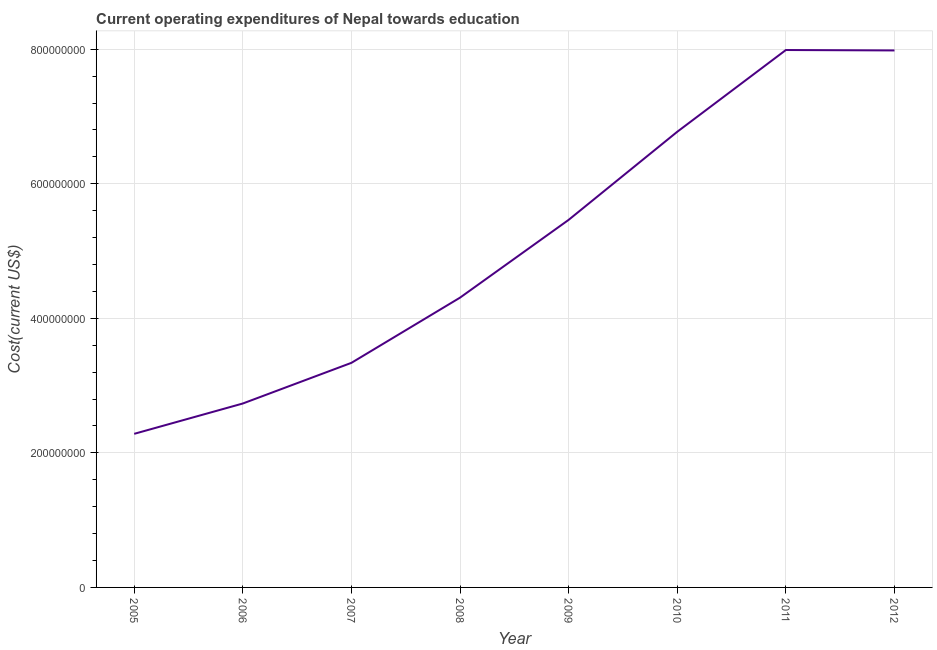What is the education expenditure in 2006?
Your answer should be very brief. 2.73e+08. Across all years, what is the maximum education expenditure?
Your answer should be compact. 7.99e+08. Across all years, what is the minimum education expenditure?
Provide a short and direct response. 2.28e+08. In which year was the education expenditure minimum?
Make the answer very short. 2005. What is the sum of the education expenditure?
Provide a succinct answer. 4.09e+09. What is the difference between the education expenditure in 2005 and 2009?
Ensure brevity in your answer.  -3.18e+08. What is the average education expenditure per year?
Keep it short and to the point. 5.11e+08. What is the median education expenditure?
Your response must be concise. 4.89e+08. In how many years, is the education expenditure greater than 720000000 US$?
Ensure brevity in your answer.  2. What is the ratio of the education expenditure in 2008 to that in 2011?
Offer a terse response. 0.54. What is the difference between the highest and the second highest education expenditure?
Your response must be concise. 6.22e+05. Is the sum of the education expenditure in 2005 and 2011 greater than the maximum education expenditure across all years?
Provide a short and direct response. Yes. What is the difference between the highest and the lowest education expenditure?
Your answer should be very brief. 5.70e+08. In how many years, is the education expenditure greater than the average education expenditure taken over all years?
Offer a terse response. 4. How many years are there in the graph?
Offer a very short reply. 8. What is the difference between two consecutive major ticks on the Y-axis?
Give a very brief answer. 2.00e+08. Are the values on the major ticks of Y-axis written in scientific E-notation?
Your answer should be compact. No. Does the graph contain any zero values?
Offer a terse response. No. What is the title of the graph?
Provide a short and direct response. Current operating expenditures of Nepal towards education. What is the label or title of the Y-axis?
Ensure brevity in your answer.  Cost(current US$). What is the Cost(current US$) in 2005?
Offer a very short reply. 2.28e+08. What is the Cost(current US$) in 2006?
Give a very brief answer. 2.73e+08. What is the Cost(current US$) in 2007?
Your answer should be compact. 3.34e+08. What is the Cost(current US$) of 2008?
Offer a very short reply. 4.31e+08. What is the Cost(current US$) of 2009?
Provide a succinct answer. 5.46e+08. What is the Cost(current US$) of 2010?
Ensure brevity in your answer.  6.77e+08. What is the Cost(current US$) of 2011?
Make the answer very short. 7.99e+08. What is the Cost(current US$) of 2012?
Offer a very short reply. 7.98e+08. What is the difference between the Cost(current US$) in 2005 and 2006?
Offer a terse response. -4.51e+07. What is the difference between the Cost(current US$) in 2005 and 2007?
Give a very brief answer. -1.06e+08. What is the difference between the Cost(current US$) in 2005 and 2008?
Ensure brevity in your answer.  -2.02e+08. What is the difference between the Cost(current US$) in 2005 and 2009?
Make the answer very short. -3.18e+08. What is the difference between the Cost(current US$) in 2005 and 2010?
Your response must be concise. -4.49e+08. What is the difference between the Cost(current US$) in 2005 and 2011?
Your answer should be compact. -5.70e+08. What is the difference between the Cost(current US$) in 2005 and 2012?
Offer a very short reply. -5.70e+08. What is the difference between the Cost(current US$) in 2006 and 2007?
Provide a short and direct response. -6.04e+07. What is the difference between the Cost(current US$) in 2006 and 2008?
Your response must be concise. -1.57e+08. What is the difference between the Cost(current US$) in 2006 and 2009?
Provide a short and direct response. -2.73e+08. What is the difference between the Cost(current US$) in 2006 and 2010?
Give a very brief answer. -4.04e+08. What is the difference between the Cost(current US$) in 2006 and 2011?
Your answer should be compact. -5.25e+08. What is the difference between the Cost(current US$) in 2006 and 2012?
Your answer should be very brief. -5.25e+08. What is the difference between the Cost(current US$) in 2007 and 2008?
Your answer should be very brief. -9.69e+07. What is the difference between the Cost(current US$) in 2007 and 2009?
Provide a succinct answer. -2.13e+08. What is the difference between the Cost(current US$) in 2007 and 2010?
Give a very brief answer. -3.43e+08. What is the difference between the Cost(current US$) in 2007 and 2011?
Make the answer very short. -4.65e+08. What is the difference between the Cost(current US$) in 2007 and 2012?
Offer a terse response. -4.64e+08. What is the difference between the Cost(current US$) in 2008 and 2009?
Provide a short and direct response. -1.16e+08. What is the difference between the Cost(current US$) in 2008 and 2010?
Provide a short and direct response. -2.47e+08. What is the difference between the Cost(current US$) in 2008 and 2011?
Your answer should be very brief. -3.68e+08. What is the difference between the Cost(current US$) in 2008 and 2012?
Make the answer very short. -3.67e+08. What is the difference between the Cost(current US$) in 2009 and 2010?
Give a very brief answer. -1.31e+08. What is the difference between the Cost(current US$) in 2009 and 2011?
Your answer should be compact. -2.52e+08. What is the difference between the Cost(current US$) in 2009 and 2012?
Your response must be concise. -2.52e+08. What is the difference between the Cost(current US$) in 2010 and 2011?
Make the answer very short. -1.22e+08. What is the difference between the Cost(current US$) in 2010 and 2012?
Your answer should be very brief. -1.21e+08. What is the difference between the Cost(current US$) in 2011 and 2012?
Offer a very short reply. 6.22e+05. What is the ratio of the Cost(current US$) in 2005 to that in 2006?
Make the answer very short. 0.83. What is the ratio of the Cost(current US$) in 2005 to that in 2007?
Ensure brevity in your answer.  0.68. What is the ratio of the Cost(current US$) in 2005 to that in 2008?
Give a very brief answer. 0.53. What is the ratio of the Cost(current US$) in 2005 to that in 2009?
Provide a succinct answer. 0.42. What is the ratio of the Cost(current US$) in 2005 to that in 2010?
Your answer should be compact. 0.34. What is the ratio of the Cost(current US$) in 2005 to that in 2011?
Your response must be concise. 0.29. What is the ratio of the Cost(current US$) in 2005 to that in 2012?
Your answer should be very brief. 0.29. What is the ratio of the Cost(current US$) in 2006 to that in 2007?
Offer a very short reply. 0.82. What is the ratio of the Cost(current US$) in 2006 to that in 2008?
Offer a very short reply. 0.64. What is the ratio of the Cost(current US$) in 2006 to that in 2010?
Provide a short and direct response. 0.4. What is the ratio of the Cost(current US$) in 2006 to that in 2011?
Provide a short and direct response. 0.34. What is the ratio of the Cost(current US$) in 2006 to that in 2012?
Offer a terse response. 0.34. What is the ratio of the Cost(current US$) in 2007 to that in 2008?
Provide a short and direct response. 0.78. What is the ratio of the Cost(current US$) in 2007 to that in 2009?
Make the answer very short. 0.61. What is the ratio of the Cost(current US$) in 2007 to that in 2010?
Provide a short and direct response. 0.49. What is the ratio of the Cost(current US$) in 2007 to that in 2011?
Your response must be concise. 0.42. What is the ratio of the Cost(current US$) in 2007 to that in 2012?
Keep it short and to the point. 0.42. What is the ratio of the Cost(current US$) in 2008 to that in 2009?
Your answer should be very brief. 0.79. What is the ratio of the Cost(current US$) in 2008 to that in 2010?
Your answer should be compact. 0.64. What is the ratio of the Cost(current US$) in 2008 to that in 2011?
Your answer should be very brief. 0.54. What is the ratio of the Cost(current US$) in 2008 to that in 2012?
Your answer should be very brief. 0.54. What is the ratio of the Cost(current US$) in 2009 to that in 2010?
Provide a short and direct response. 0.81. What is the ratio of the Cost(current US$) in 2009 to that in 2011?
Your response must be concise. 0.68. What is the ratio of the Cost(current US$) in 2009 to that in 2012?
Provide a succinct answer. 0.69. What is the ratio of the Cost(current US$) in 2010 to that in 2011?
Your answer should be compact. 0.85. What is the ratio of the Cost(current US$) in 2010 to that in 2012?
Offer a terse response. 0.85. 